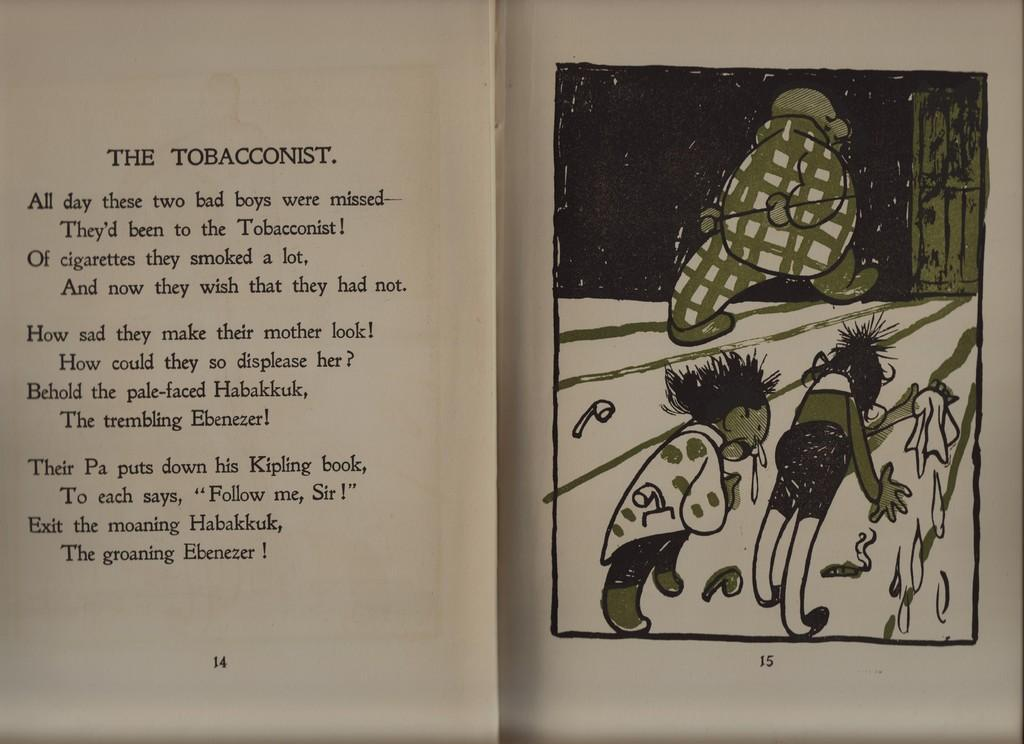<image>
Create a compact narrative representing the image presented. A cartoon depiction of kids around smoking pipes in a book called The Tobacconist. 